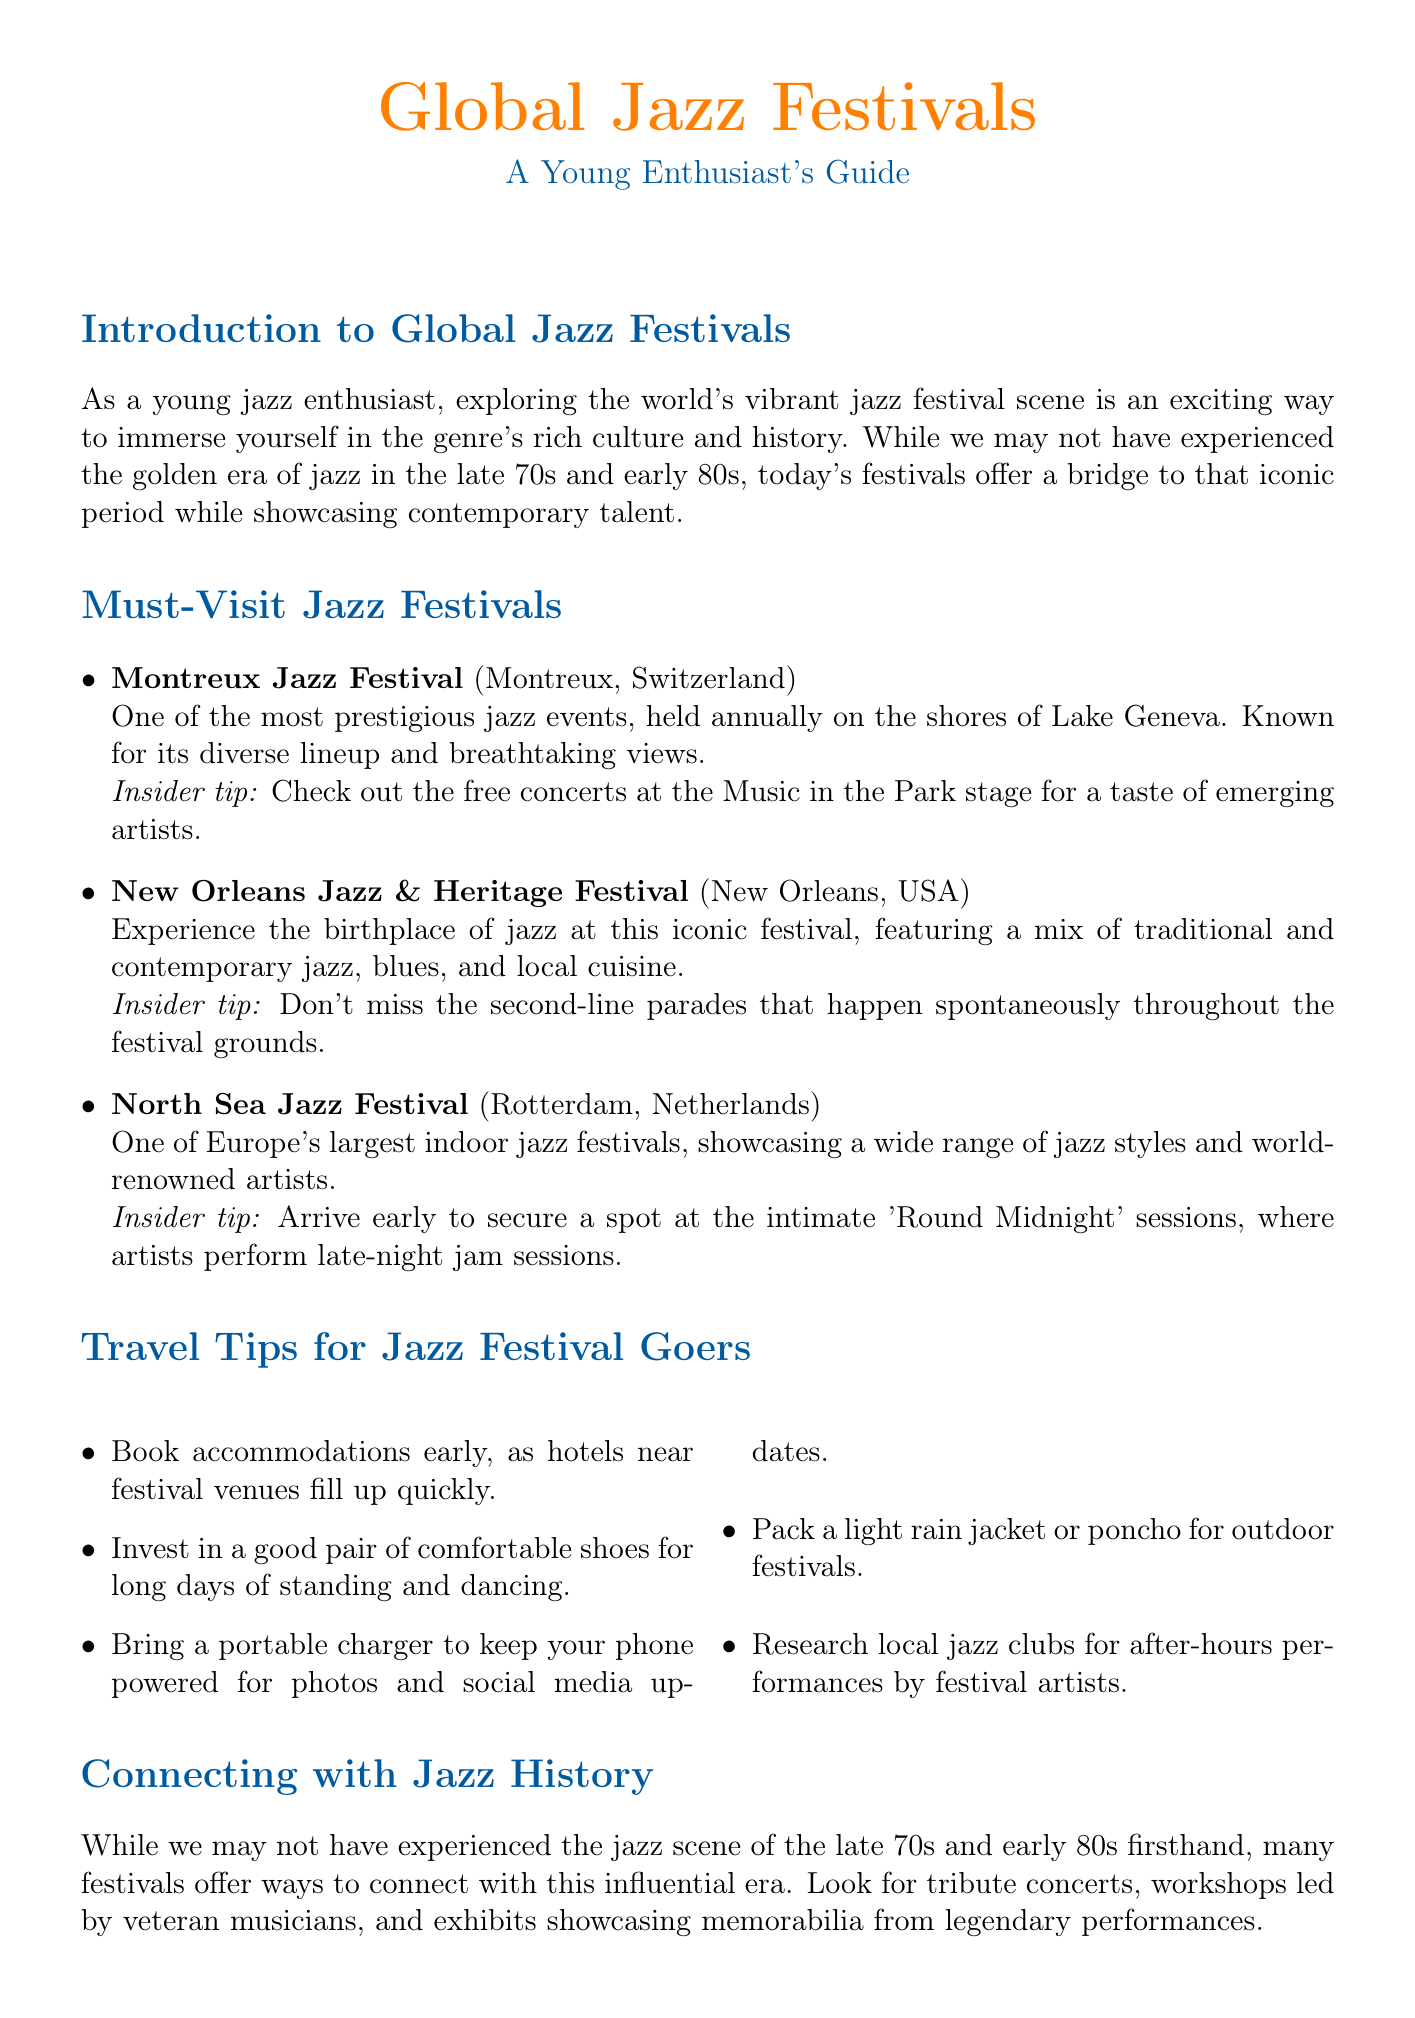What is the location of the Montreux Jazz Festival? The document states that the Montreux Jazz Festival is held in Montreux, Switzerland.
Answer: Montreux, Switzerland What type of music is primarily featured at the New Orleans Jazz & Heritage Festival? The festival features a mix of traditional and contemporary jazz, blues, and local cuisine.
Answer: Jazz, blues What insider tip is given for the North Sea Jazz Festival? The document mentions that attendees should arrive early to secure a spot at the intimate 'Round Midnight' sessions.
Answer: Arrive early for 'Round Midnight' sessions How many travel tips are provided for jazz festival goers? There are five travel tips listed in the document.
Answer: Five What is a recommended activity during the Jakarta International Java Jazz Festival? The document suggests exploring the 'Jazz for Tomorrow' stage to discover promising young Indonesian jazz artists.
Answer: Explore 'Jazz for Tomorrow' stage What number of sections are there in the newsletter? Counting each title provided, there are seven distinct sections in the newsletter.
Answer: Seven What is the purpose of the etiquette section in the document? The etiquette section provides guidelines for respecting artists and the audience during performances.
Answer: Guidelines for respect during performances Which festival offers free concerts in Rynok Square? The Alfa Jazz Fest is noted for free concerts in Rynok Square in the document.
Answer: Alfa Jazz Fest What does the introduction state about the current jazz festivals? The introduction highlights that today's festivals offer a bridge to the iconic jazz period while showcasing contemporary talent.
Answer: Bridge to iconic period and contemporary talent 